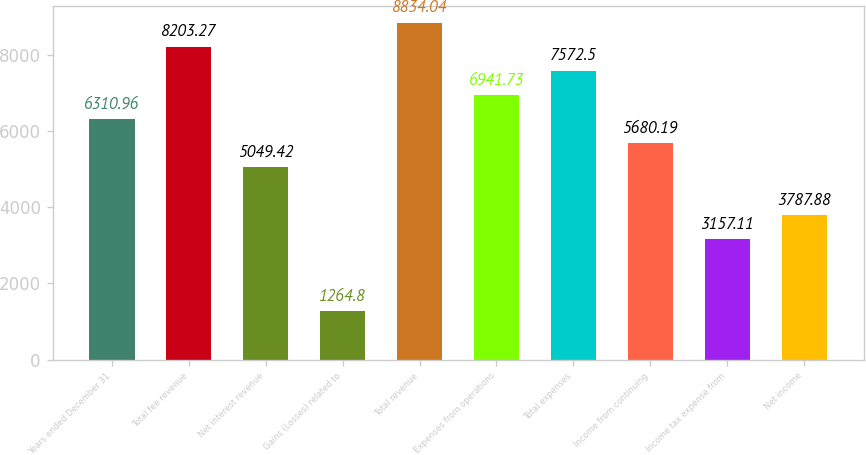Convert chart. <chart><loc_0><loc_0><loc_500><loc_500><bar_chart><fcel>Years ended December 31<fcel>Total fee revenue<fcel>Net interest revenue<fcel>Gains (Losses) related to<fcel>Total revenue<fcel>Expenses from operations<fcel>Total expenses<fcel>Income from continuing<fcel>Income tax expense from<fcel>Net income<nl><fcel>6310.96<fcel>8203.27<fcel>5049.42<fcel>1264.8<fcel>8834.04<fcel>6941.73<fcel>7572.5<fcel>5680.19<fcel>3157.11<fcel>3787.88<nl></chart> 